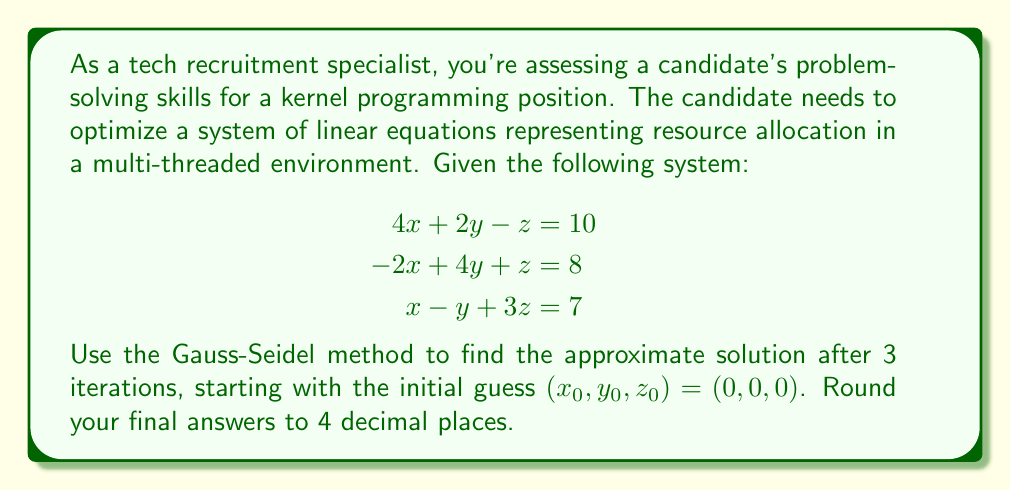Provide a solution to this math problem. To solve this system using the Gauss-Seidel method, we'll follow these steps:

1) First, rearrange the equations to isolate x, y, and z:

   $$x = \frac{10 - 2y + z}{4}$$
   $$y = \frac{8 + 2x - z}{4}$$
   $$z = \frac{7 - x + y}{3}$$

2) Now, we'll perform 3 iterations, using the most recent values for each variable as we calculate the next:

   Iteration 1:
   $$x_1 = \frac{10 - 2(0) + 0}{4} = 2.5000$$
   $$y_1 = \frac{8 + 2(2.5000) - 0}{4} = 3.2500$$
   $$z_1 = \frac{7 - 2.5000 + 3.2500}{3} = 2.5833$$

   Iteration 2:
   $$x_2 = \frac{10 - 2(3.2500) + 2.5833}{4} = 1.5208$$
   $$y_2 = \frac{8 + 2(1.5208) - 2.5833}{4} = 2.1146$$
   $$z_2 = \frac{7 - 1.5208 + 2.1146}{3} = 2.5313$$

   Iteration 3:
   $$x_3 = \frac{10 - 2(2.1146) + 2.5313}{4} = 2.0755$$
   $$y_3 = \frac{8 + 2(2.0755) - 2.5313}{4} = 2.4049$$
   $$z_3 = \frac{7 - 2.0755 + 2.4049}{3} = 2.4431$$

3) Rounding to 4 decimal places, we get our final approximation.
Answer: After 3 iterations of the Gauss-Seidel method, the approximate solution is:
$$(x, y, z) \approx (2.0755, 2.4049, 2.4431)$$ 